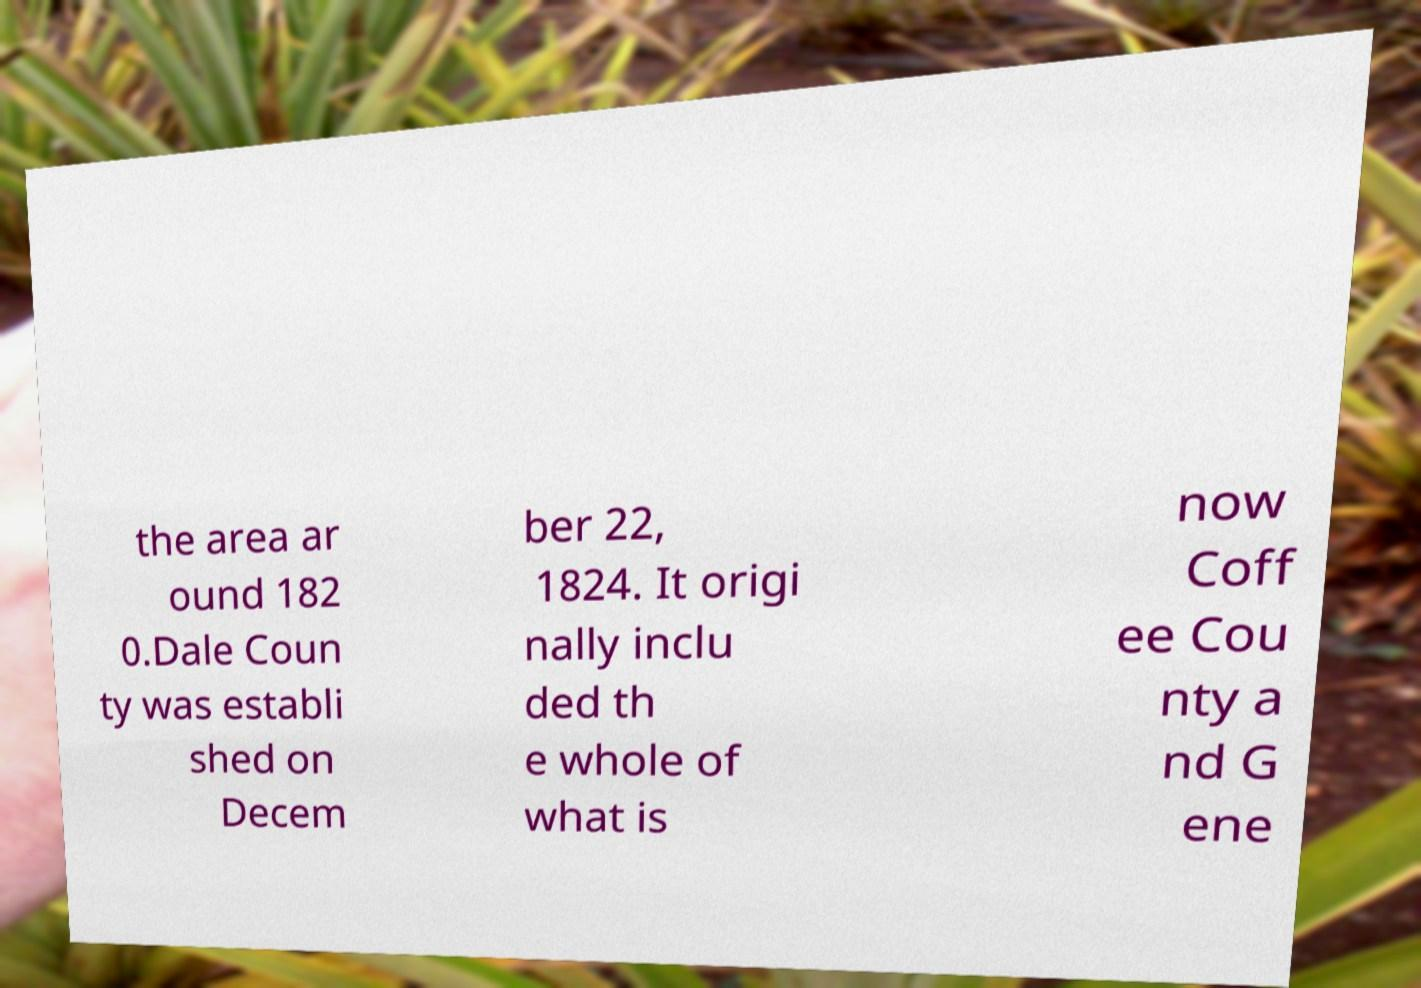Could you assist in decoding the text presented in this image and type it out clearly? the area ar ound 182 0.Dale Coun ty was establi shed on Decem ber 22, 1824. It origi nally inclu ded th e whole of what is now Coff ee Cou nty a nd G ene 